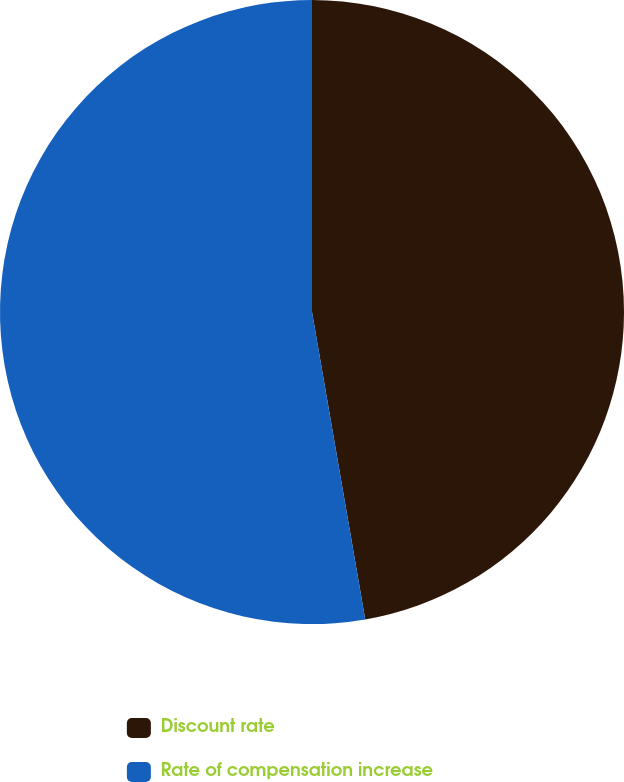<chart> <loc_0><loc_0><loc_500><loc_500><pie_chart><fcel>Discount rate<fcel>Rate of compensation increase<nl><fcel>47.27%<fcel>52.73%<nl></chart> 